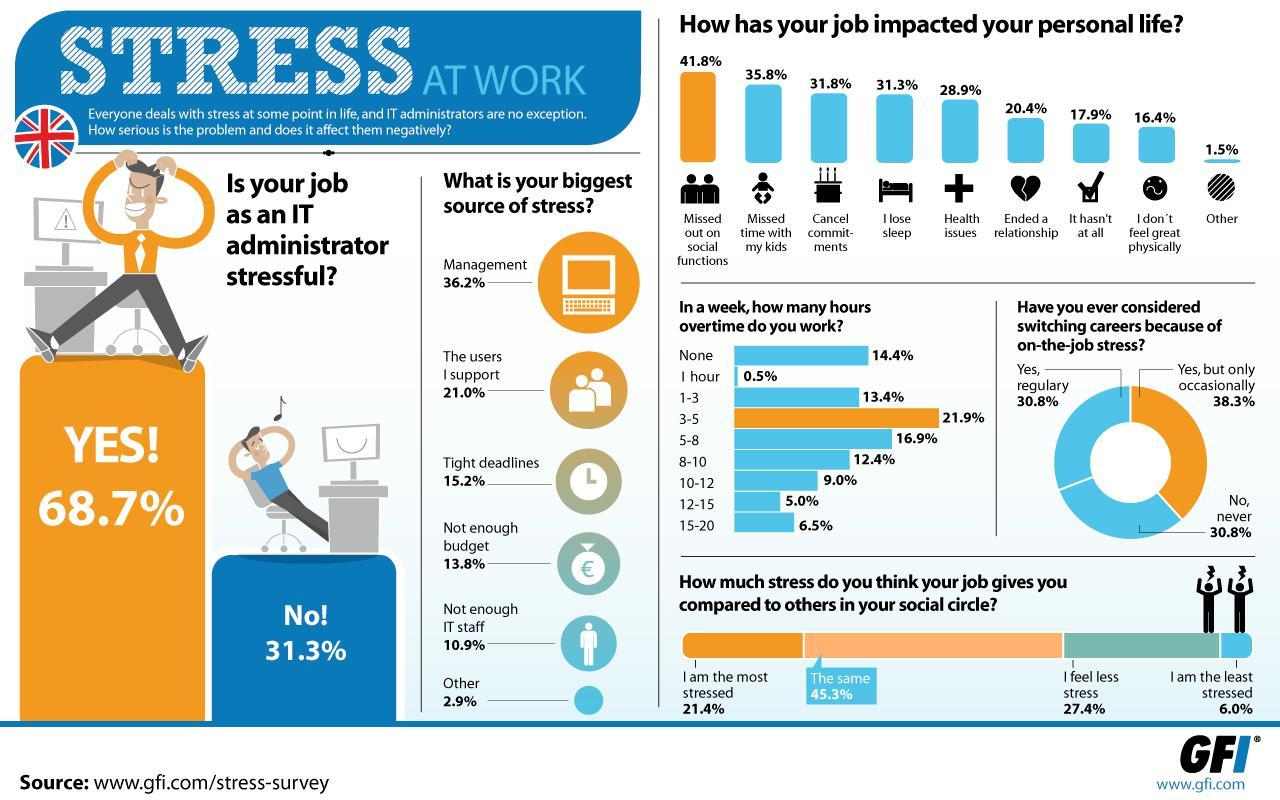How many hours of overtime is done by 13.4% of the UK employees?
Answer the question with a short phrase. 1-3 What percentage of people in UK missed time with their kids because of their stressful job? 35.8% What percent of people in UK considered switching their jobs regularly because of the job stress? 30.8% What percent of people working as an IT administrator in UK felt stressed at work? 68.7% What percent of people in UK never considered switching their jobs because of the job stress? 30.8% What percentage of people in UK ended a relationship because of their stressful job? 20.4% What percentage of employees in UK consider tight deadlines as the biggest source of stress? 15.2% How many hours of overtime is done by majority of the employees in UK? 3-5 